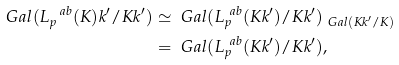<formula> <loc_0><loc_0><loc_500><loc_500>\ G a l ( L _ { p } ^ { \ a b } ( K ) k ^ { \prime } / K k ^ { \prime } ) & \simeq \ G a l ( L _ { p } ^ { \ a b } ( K k ^ { \prime } ) / K k ^ { \prime } ) _ { \ G a l ( K k ^ { \prime } / K ) } \\ & = \ G a l ( L _ { p } ^ { \ a b } ( K k ^ { \prime } ) / K k ^ { \prime } ) ,</formula> 